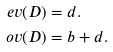Convert formula to latex. <formula><loc_0><loc_0><loc_500><loc_500>e v ( D ) & = d . \\ o v ( D ) & = b + d .</formula> 